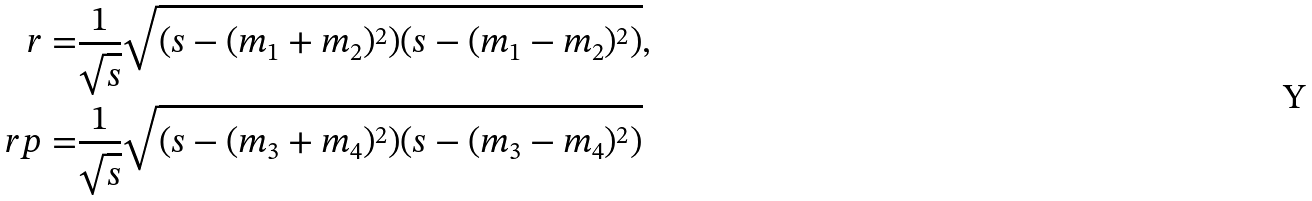Convert formula to latex. <formula><loc_0><loc_0><loc_500><loc_500>r = & \frac { 1 } { \sqrt { s } } \sqrt { ( s - ( m _ { 1 } + m _ { 2 } ) ^ { 2 } ) ( s - ( m _ { 1 } - m _ { 2 } ) ^ { 2 } ) } , \\ \ r p = & \frac { 1 } { \sqrt { s } } \sqrt { ( s - ( m _ { 3 } + m _ { 4 } ) ^ { 2 } ) ( s - ( m _ { 3 } - m _ { 4 } ) ^ { 2 } ) }</formula> 